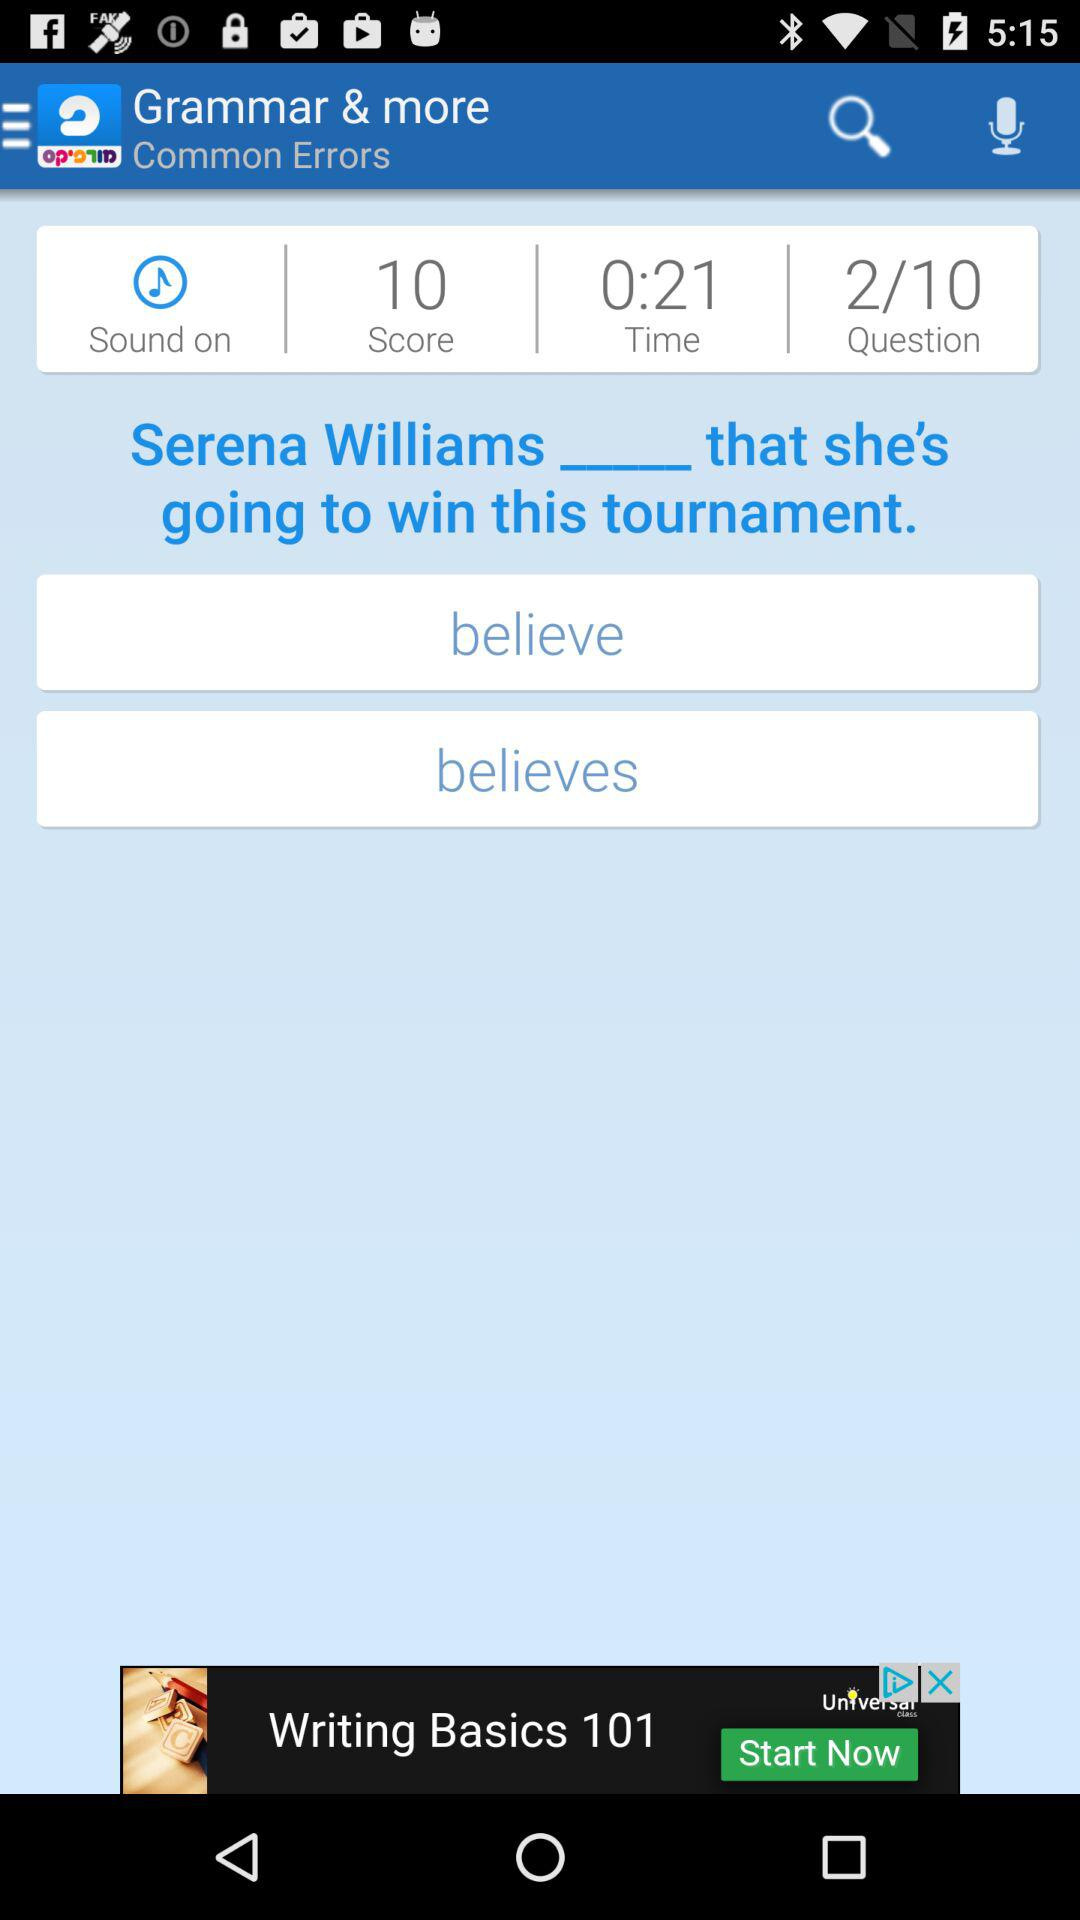What is the status of "Sound"? The status is "on". 